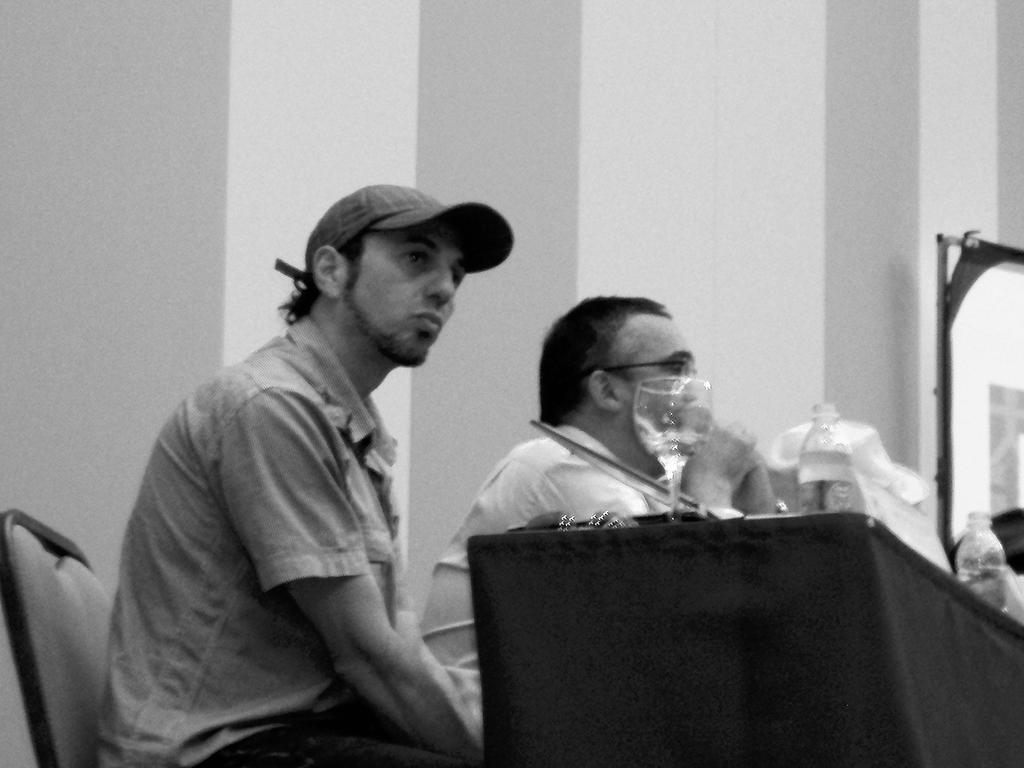What is the color scheme of the image? The image is black and white. What are the two men in the image doing? The two men are sitting on chairs. What is on the table in the image? There is a table with glass, bottles, and other objects on it. What can be seen in the background of the image? There is a wall in the background of the image. How many cushions are on the chairs in the image? There is no mention of cushions on the chairs in the image. What is the aftermath of the event depicted in the image? There is no event depicted in the image, so it's not possible to determine the aftermath. 